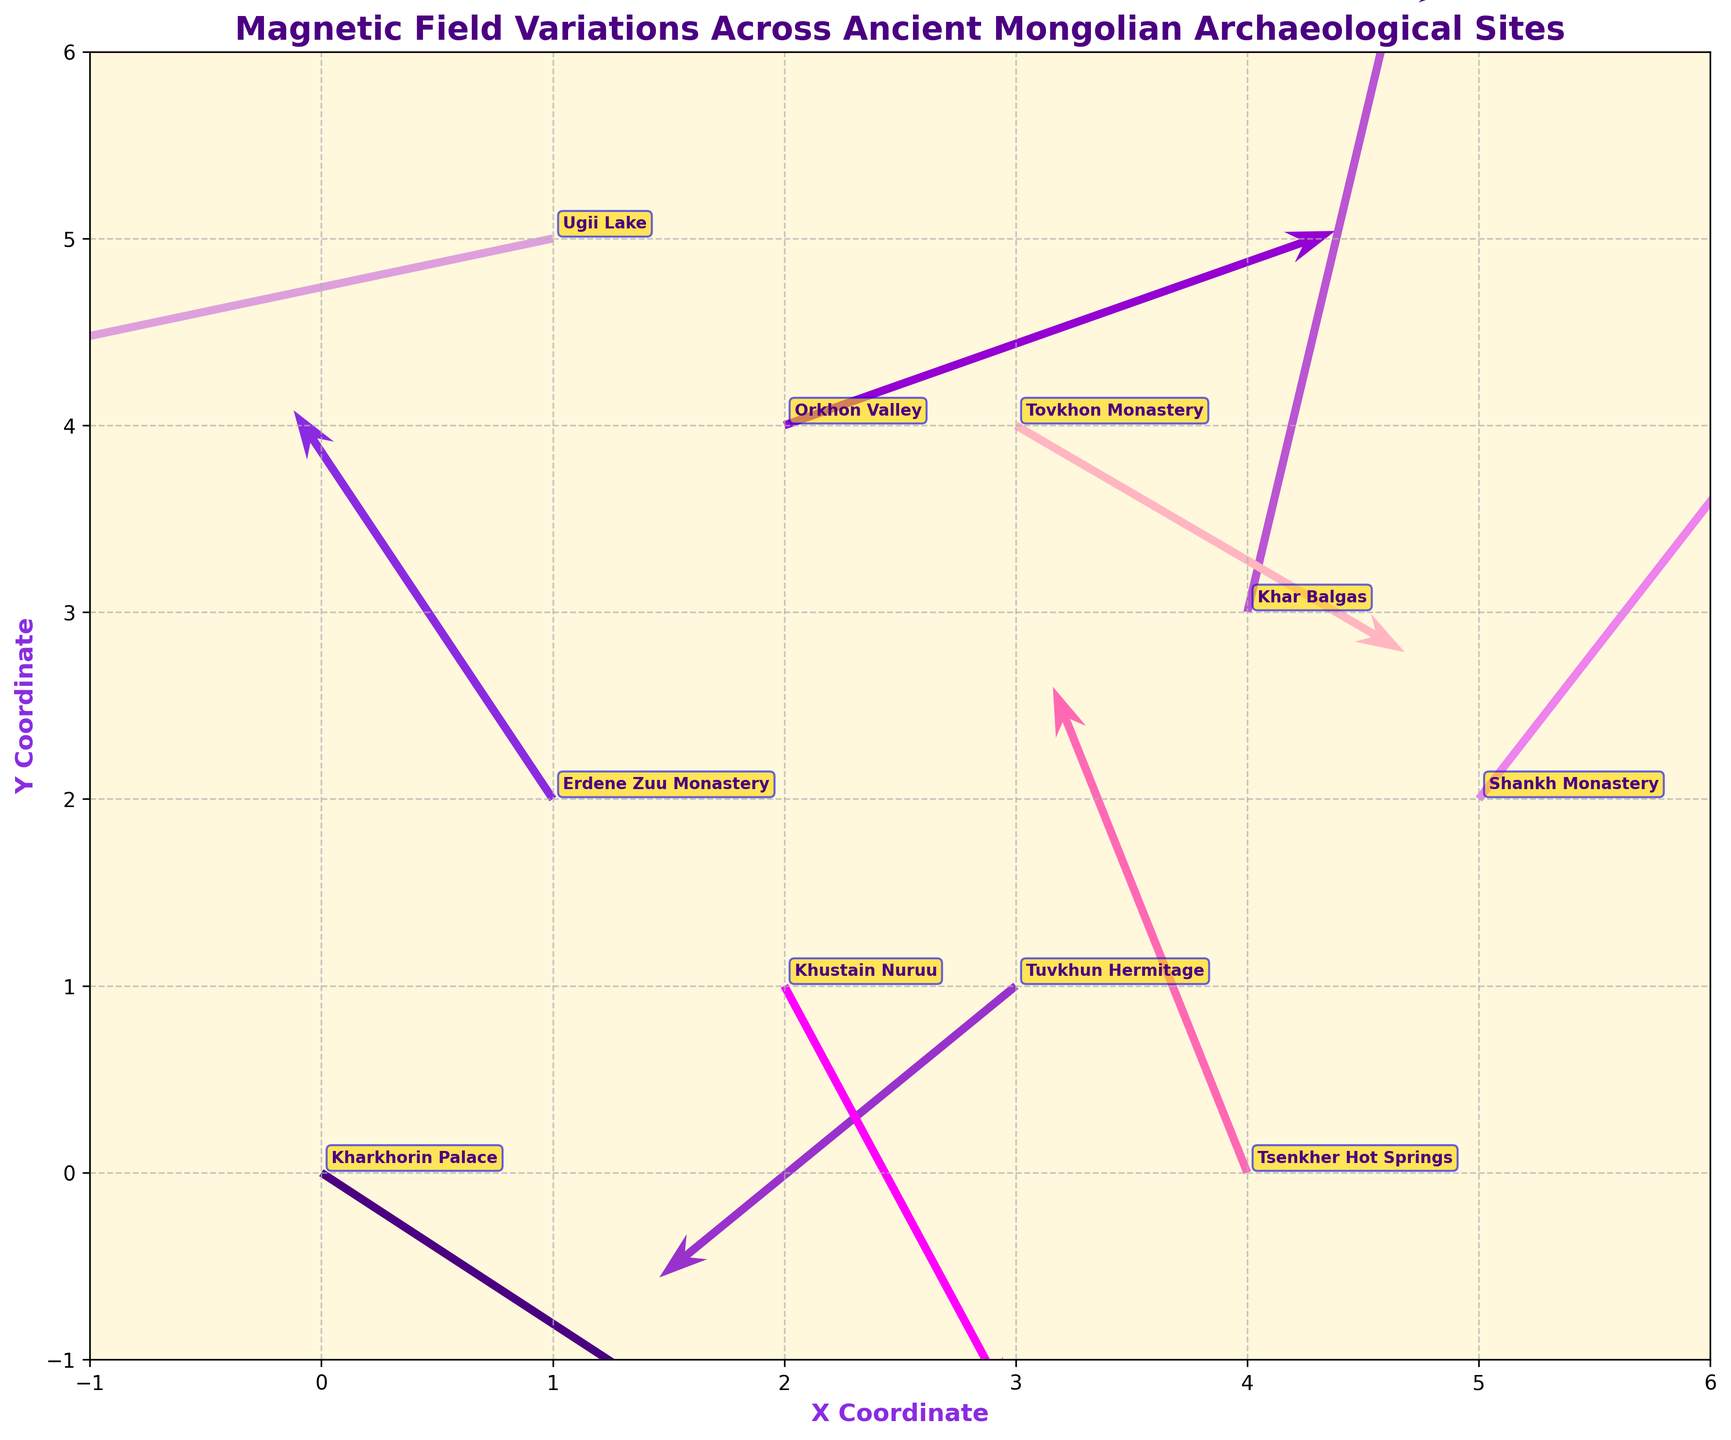What is the title of the figure? The title is prominently displayed at the top of the figure. It reads "Magnetic Field Variations Across Ancient Mongolian Archaeological Sites".
Answer: Magnetic Field Variations Across Ancient Mongolian Archaeological Sites Which site shows the largest positive u-component of the magnetic field? To find this, compare the u-values for all the sites. The largest positive u-component is 2.3 at Kharkhorin Palace.
Answer: Kharkhorin Palace Which site has the magnetic field vector pointing towards (downward left)? The vector pointing downward left will have both negative u and v components. Cross-referencing, Tuvkhun Hermitage has both u = -1.1 and v = -0.9, indicating a downward left direction.
Answer: Tuvkhun Hermitage What are the coordinates of Shankh Monastery? Locate Shankh Monastery on the plot, which is annotated with its name. The coordinates given in the data are x = 5 and y = 2.
Answer: (5, 2) Which site has the magnetic field vector pointing the most upward? The vector with the largest positive v-component is the most upward. Khar Balgas has the largest positive v-component of 2.1.
Answer: Khar Balgas Compare Kharkhorin Palace and Tsenkher Hot Springs. Which one has a stronger magnetic field vector? To compare, calculate the magnitude of the vectors. Kharkhorin Palace (2.3,-1.5) and Tsenkher Hot Springs (-0.6,1.5). Their magnitudes are sqrt(2.3^2 + (-1.5)^2) = 2.75 and sqrt((-0.6)^2 + 1.5^2) = 1.62 respectively. Kharkhorin Palace has a stronger vector.
Answer: Kharkhorin Palace How many sites have their magnetic field vectors pointing predominantly to the left? Vectors pointing to the left will have negative u-values. Checking, Erdene Zuu Monastery, Tuvkhun Hermitage, Ugii Lake, and Tsenkher Hot Springs have negative u-values. Four sites in total.
Answer: 4 What's the direction of the magnetic field at Ugii Lake? Locate the vector for Ugii Lake, which has components u = -1.9 and v = -0.4. This indicates a direction towards the lower left.
Answer: Lower left What is the range of x-coordinates covered in the plot? The x-coordinates in the data range from 0 to 5.
Answer: 0 to 5 Which site has the smallest magnetic field vector? To determine this, calculate the magnitudes of each vector and identify the smallest. Ugii Lake’s vector with components (-1.9, -0.4) has a magnitude of sqrt((-1.9)^2 + (-0.4)^2) = 1.943. All other magnitudes are higher.
Answer: Ugii Lake 